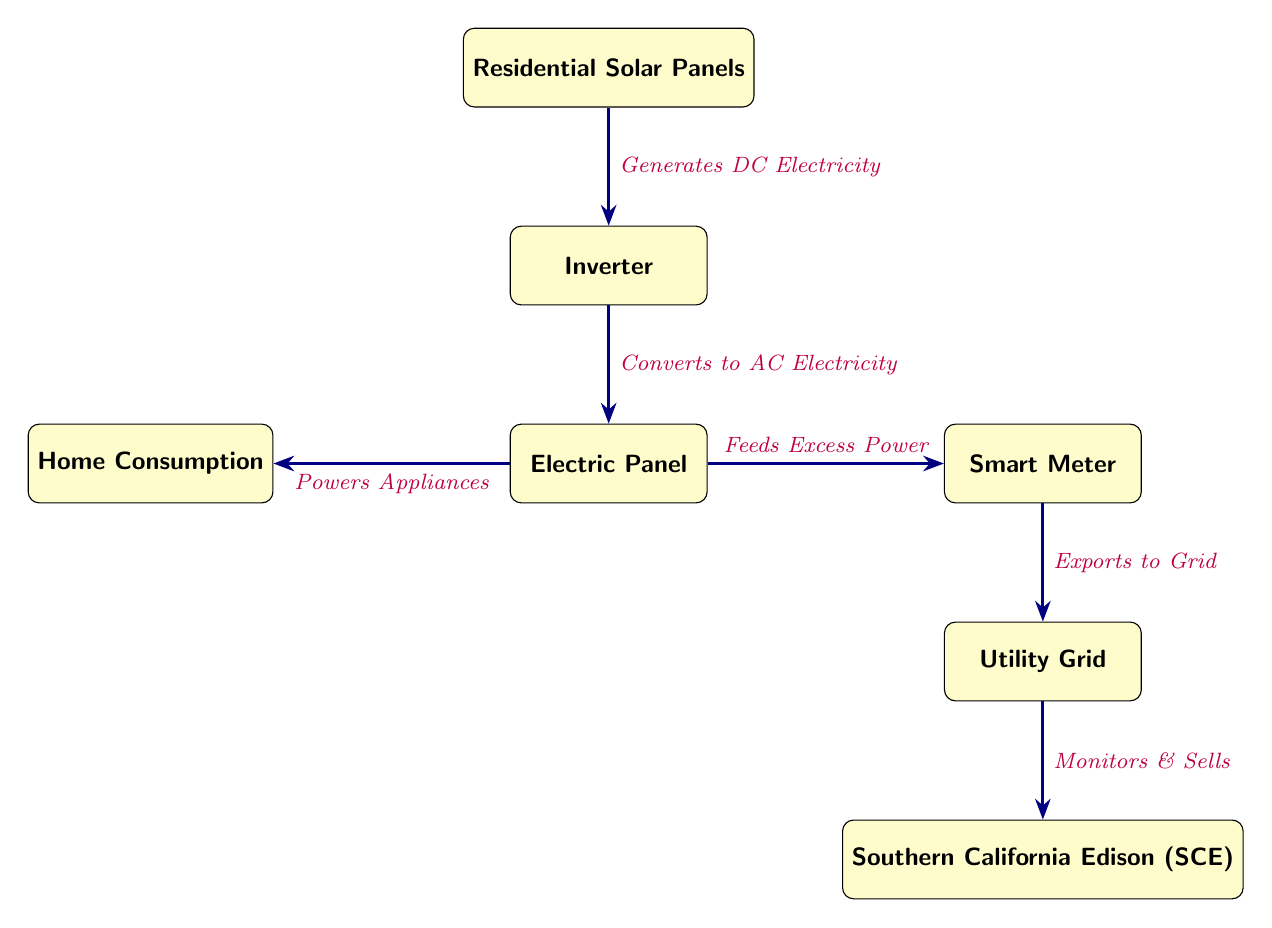What generates DC electricity? The diagram shows that Residential Solar Panels generate DC electricity. This is indicated by the arrow pointing from the Residential Solar Panels node to the Inverter node, labeled "Generates DC Electricity."
Answer: Residential Solar Panels What converts DC electricity to AC electricity? Looking at the diagram, the Inverter is responsible for converting DC electricity to AC electricity, as illustrated by the arrow from the Inverter to the Electric Panel, marked "Converts to AC Electricity."
Answer: Inverter What happens to excess power produced? The diagram indicates that excess power is fed to the Smart Meter, as shown by the arrow from the Electric Panel to the Smart Meter, labeled "Feeds Excess Power."
Answer: Feeds Excess Power How does home consumption relate to the energy flow? From the diagram, we see that the Electric Panel powers appliances in the Home, which is indicated by the arrow from the Electric Panel to the Home Consumption node, annotated "Powers Appliances."
Answer: Powers Appliances What entity monitors and sells the exported power? The exported power to the Utility Grid is monitored and sold by Southern California Edison (SCE), as depicted by the arrow from the Utility Grid to the SCE node, labeled "Monitors & Sells."
Answer: Southern California Edison (SCE) What is the total number of nodes in the diagram? Counting all the distinct nodes in the diagram, including Residential Solar Panels, Inverter, Electric Panel, Home Consumption, Smart Meter, Utility Grid, and Southern California Edison, there are seven nodes in total.
Answer: Seven What is the relationship between Smart Meter and Utility Grid? The diagram shows that the Smart Meter exports electricity to the Utility Grid, which is indicated by the arrow labeled "Exports to Grid" between the Smart Meter and Utility Grid nodes.
Answer: Exports to Grid Where does the power for home consumption come from? The diagram conveys that the power for home consumption comes from the Electric Panel, as represented by the relationship from the Electric Panel node to the Home Consumption node, labeled "Powers Appliances."
Answer: Electric Panel Who receives the exported power from residential solar panels? The Utility Grid receives the exported power, as shown by the flow from the Smart Meter to the Utility Grid, noted "Exports to Grid."
Answer: Utility Grid 